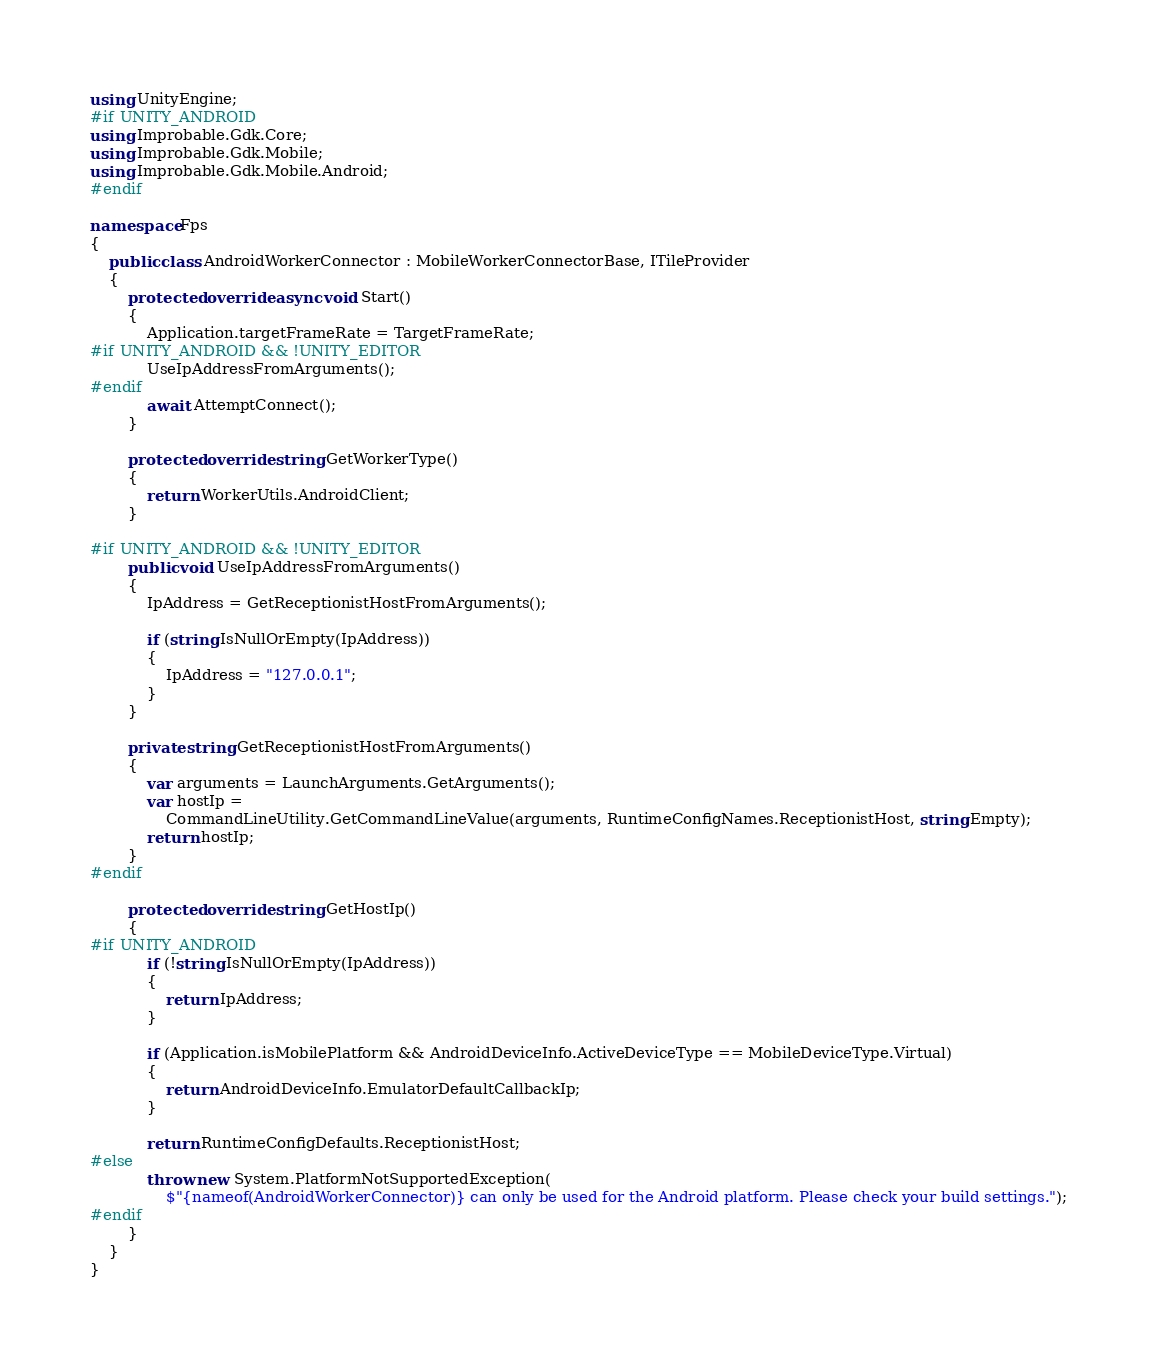<code> <loc_0><loc_0><loc_500><loc_500><_C#_>using UnityEngine;
#if UNITY_ANDROID
using Improbable.Gdk.Core;
using Improbable.Gdk.Mobile;
using Improbable.Gdk.Mobile.Android;
#endif

namespace Fps
{
    public class AndroidWorkerConnector : MobileWorkerConnectorBase, ITileProvider
    {
        protected override async void Start()
        {
            Application.targetFrameRate = TargetFrameRate;
#if UNITY_ANDROID && !UNITY_EDITOR
            UseIpAddressFromArguments();
#endif
            await AttemptConnect();
        }

        protected override string GetWorkerType()
        {
            return WorkerUtils.AndroidClient;
        }

#if UNITY_ANDROID && !UNITY_EDITOR
        public void UseIpAddressFromArguments()
        {
            IpAddress = GetReceptionistHostFromArguments();

            if (string.IsNullOrEmpty(IpAddress))
            {
                IpAddress = "127.0.0.1";
            }
        }

        private string GetReceptionistHostFromArguments()
        {
            var arguments = LaunchArguments.GetArguments();
            var hostIp =
                CommandLineUtility.GetCommandLineValue(arguments, RuntimeConfigNames.ReceptionistHost, string.Empty);
            return hostIp;
        }
#endif

        protected override string GetHostIp()
        {
#if UNITY_ANDROID
            if (!string.IsNullOrEmpty(IpAddress))
            {
                return IpAddress;
            }

            if (Application.isMobilePlatform && AndroidDeviceInfo.ActiveDeviceType == MobileDeviceType.Virtual)
            {
                return AndroidDeviceInfo.EmulatorDefaultCallbackIp;
            }

            return RuntimeConfigDefaults.ReceptionistHost;
#else
            throw new System.PlatformNotSupportedException(
                $"{nameof(AndroidWorkerConnector)} can only be used for the Android platform. Please check your build settings.");
#endif
        }
    }
}
</code> 